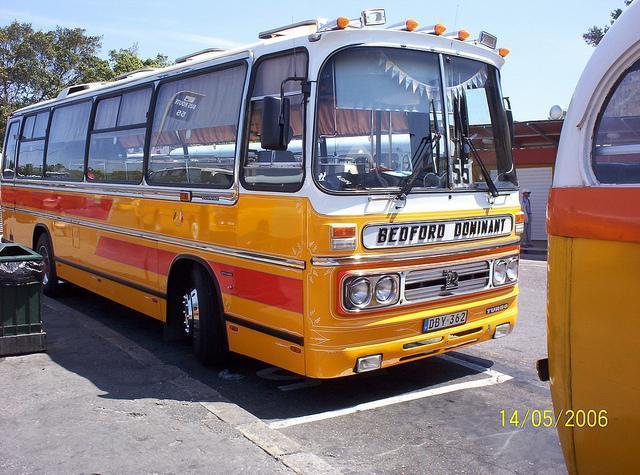How many buses are there?
Give a very brief answer. 2. 